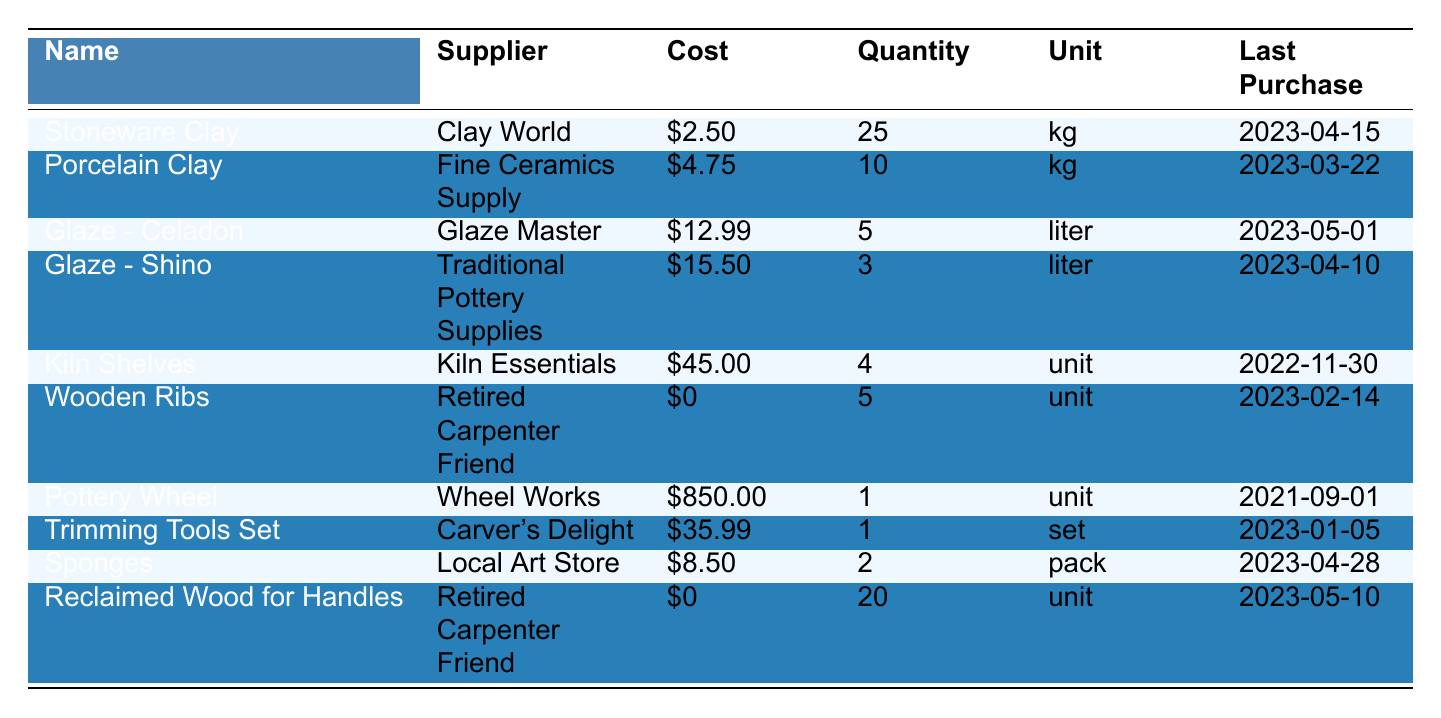What is the cost per kilogram of Stoneware Clay? The table lists "Stoneware Clay" under the "Name" column with a corresponding "Cost" of $2.50.
Answer: $2.50 How many kilograms of Porcelain Clay were purchased? The "Quantity" column shows "Porcelain Clay" has a value of 10.
Answer: 10 kg Which supplier provides the Glaze - Shino? The table indicates that "Glaze - Shino" is supplied by "Traditional Pottery Supplies."
Answer: Traditional Pottery Supplies What is the total quantity of Wooden Ribs and Reclaimed Wood for Handles combined? Wooden Ribs has a quantity of 5, and Reclaimed Wood for Handles has a quantity of 20. By adding these together, 5 + 20 = 25.
Answer: 25 units Is the cost per unit of Wooden Ribs zero? Looking at the "Cost" column for "Wooden Ribs," the value is listed as $0, confirming the statement is true.
Answer: Yes What is the most expensive item listed in the table? The "Pottery Wheel" has a cost of $850.00, which is higher than all other items in the table.
Answer: Pottery Wheel What is the average cost of the glazes? The costs for the glazes are $12.99 (Celadon) and $15.50 (Shino). Calculating the average: (12.99 + 15.50) / 2 = 14.245.
Answer: $14.25 How much does it cost for a pack of sponges? The table lists the "Sponges" at a cost of $8.50 per pack.
Answer: $8.50 How many items were last purchased from "Retired Carpenter Friend"? Both "Wooden Ribs" and "Reclaimed Wood for Handles" are purchased from "Retired Carpenter Friend," giving a total of 2 items.
Answer: 2 items If I buy all available kilograms of Stoneware Clay, how much will it cost? The cost is $2.50 per kg and there are 25 kg available; 2.50 * 25 = $62.50.
Answer: $62.50 